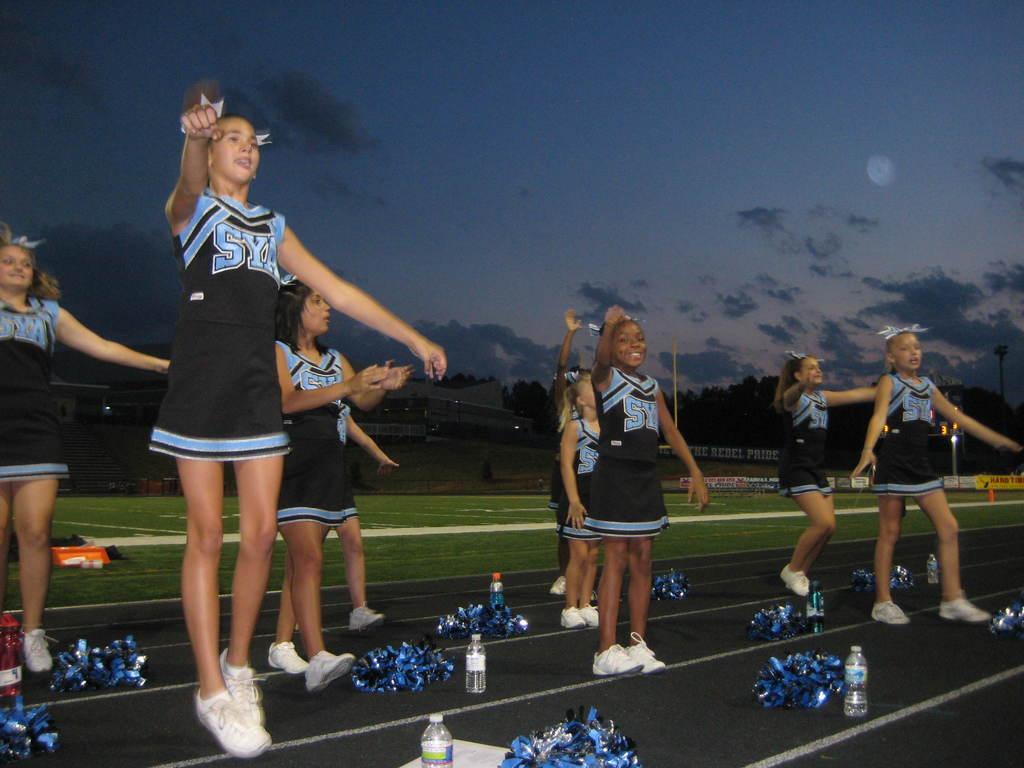What are the two letters on the girls uniforms?
Provide a short and direct response. Sy. 